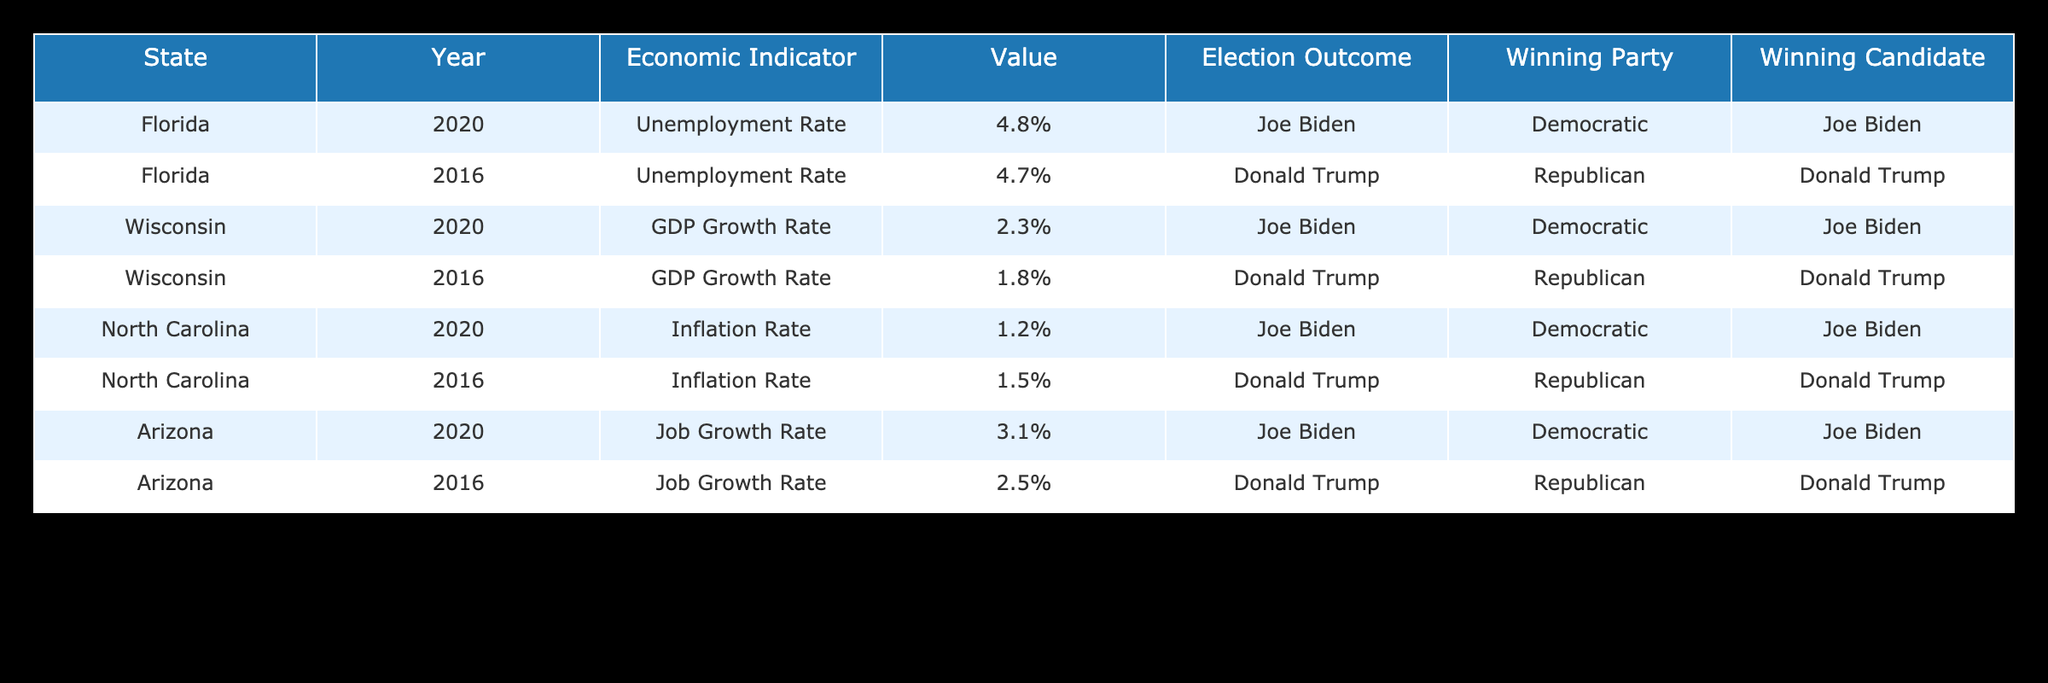What was the unemployment rate in Florida in 2020? The table shows that the unemployment rate in Florida for the year 2020 is listed under the respective row, which indicates a value of 4.8%.
Answer: 4.8% Which candidate won the election in Wisconsin in 2020? By referencing the table, we can see that Joe Biden won the election in Wisconsin in 2020 as indicated in the "Winning Candidate" column for that row.
Answer: Joe Biden What is the difference in the GDP growth rate between Wisconsin in 2020 and 2016? According to the table, the GDP growth rate for Wisconsin in 2020 is 2.3% and in 2016 it is 1.8%. The difference is calculated as 2.3% - 1.8% = 0.5%.
Answer: 0.5% Was the inflation rate higher in North Carolina in 2016 than in 2020? The inflation rates for North Carolina are 1.5% in 2016 and 1.2% in 2020, thus comparing these two values tells us that 1.5% (2016) is greater than 1.2% (2020).
Answer: Yes Considering the states listed, which candidate had the higher job growth rate in Arizona: Biden in 2020 or Trump in 2016? In the table, the job growth rate for Biden in Arizona in 2020 is 3.1%, while for Trump in 2016 it is 2.5%. Comparing these numbers shows that 3.1% is higher than 2.5%.
Answer: Biden What is the average unemployment rate from the data provided for Florida across the two years? The unemployment rates for Florida are 4.8% (2020) and 4.7% (2016). To find the average, we add these values: 4.8% + 4.7% = 9.5%, and then divide by 2, giving 9.5% / 2 = 4.75%.
Answer: 4.75% Is it true that the Democratic party won in all states for the elections in 2020? In the table, we look at the winning parties for 2020: Democratic in Florida, Wisconsin, North Carolina, and Arizona indicates that the Democratic party won in all specified states for that year.
Answer: Yes Which state showed the highest job growth rate in 2020? By examining the table, the job growth rates are noted for each state in 2020: Arizona at 3.1%, Wisconsin at 2.3%, and others. Arizona has the highest value at 3.1%.
Answer: Arizona 